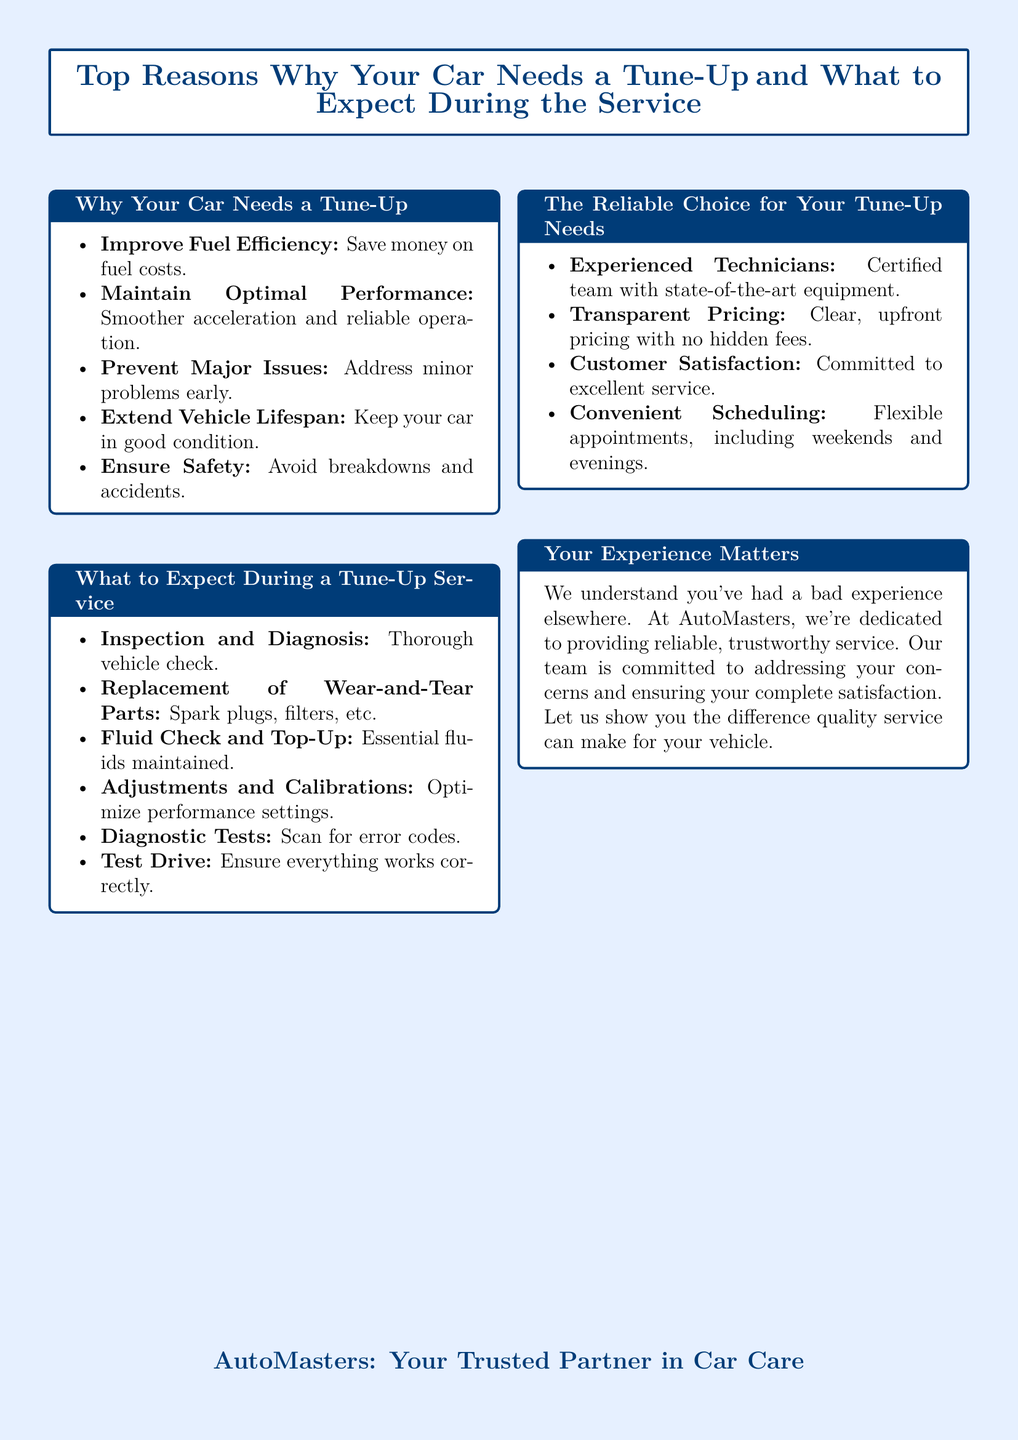What is the main purpose of a tune-up? The main purpose of a tune-up is to improve fuel efficiency, maintain optimal performance, prevent major issues, extend vehicle lifespan, and ensure safety.
Answer: Improve fuel efficiency What is one category of what to expect during a tune-up? One category includes inspection and diagnosis, which refers to thoroughly checking the vehicle.
Answer: Inspection and Diagnosis Which service aspect involves checking essential fluids? This aspect is referred to as fluid check and top-up, where essential fluids are maintained.
Answer: Fluid Check and Top-Up What is a benefit of choosing AutoMasters for a tune-up? A benefit includes customer satisfaction, which indicates a commitment to excellent service.
Answer: Customer Satisfaction How are the technicians at AutoMasters described? The technicians are described as experienced and certified, which emphasizes their qualifications and expertise.
Answer: Experienced Technicians What is the assurance provided regarding pricing? The assurance provided is that pricing is transparent, meaning clear and upfront prices without hidden fees.
Answer: Transparent Pricing What is included in the diagnostics during a tune-up? The diagnostics include diagnostic tests that scan for error codes in the vehicle.
Answer: Diagnostic Tests What does the document emphasize about customer experiences? The document emphasizes that customer experience matters, particularly focusing on addressing concerns and ensuring satisfaction.
Answer: Your Experience Matters How often should a vehicle ideally undergo a tune-up? Although the document does not specify, a common recommendation is approximately every 10,000 miles or once a year, depending on usage.
Answer: Periodically (commonly every 10,000 miles) 